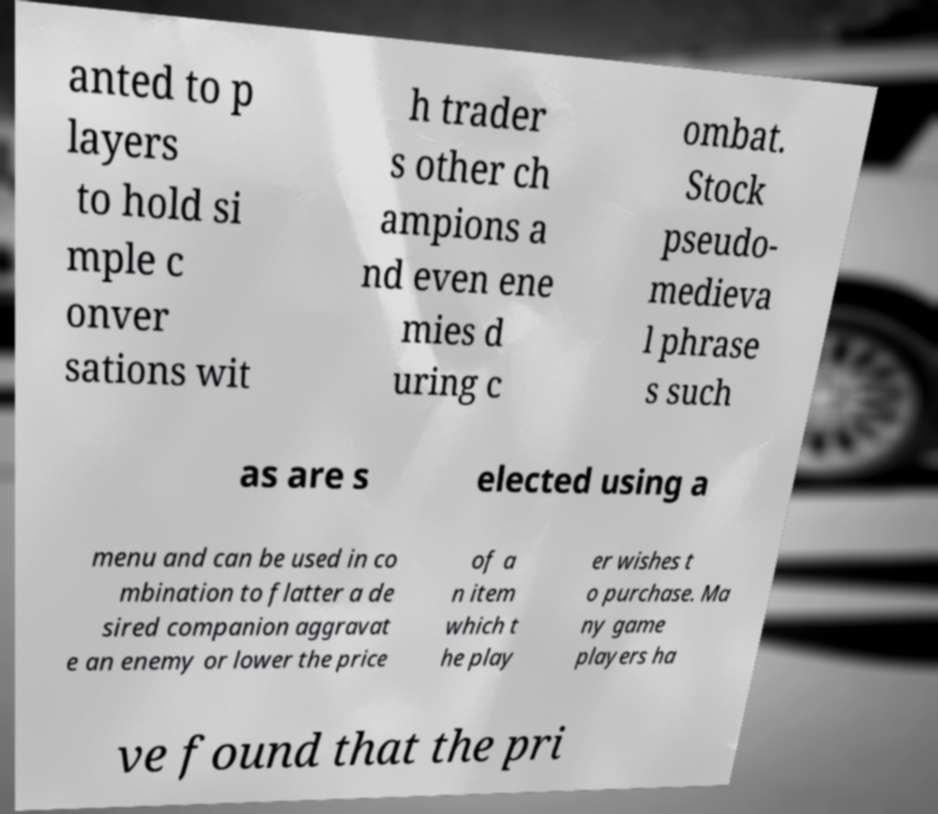What messages or text are displayed in this image? I need them in a readable, typed format. anted to p layers to hold si mple c onver sations wit h trader s other ch ampions a nd even ene mies d uring c ombat. Stock pseudo- medieva l phrase s such as are s elected using a menu and can be used in co mbination to flatter a de sired companion aggravat e an enemy or lower the price of a n item which t he play er wishes t o purchase. Ma ny game players ha ve found that the pri 